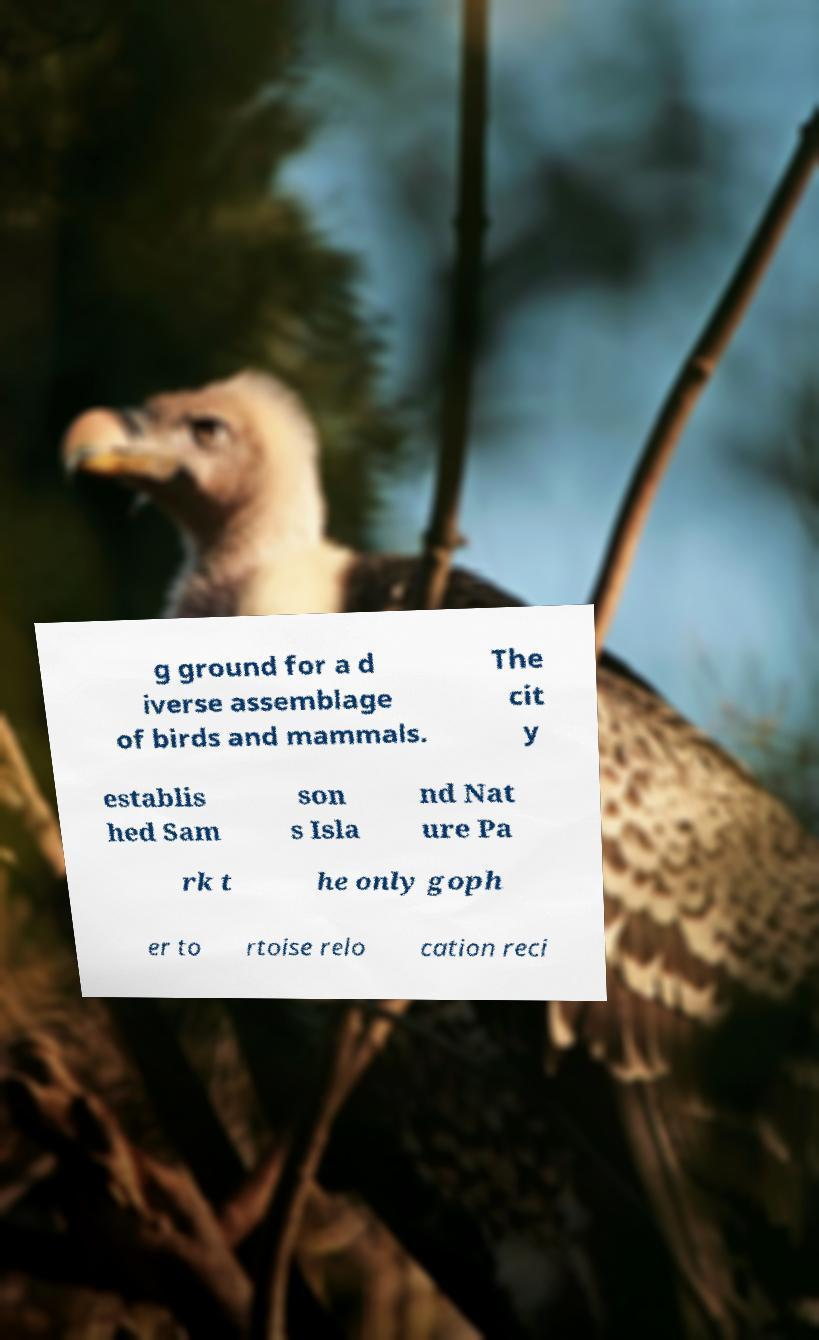There's text embedded in this image that I need extracted. Can you transcribe it verbatim? g ground for a d iverse assemblage of birds and mammals. The cit y establis hed Sam son s Isla nd Nat ure Pa rk t he only goph er to rtoise relo cation reci 